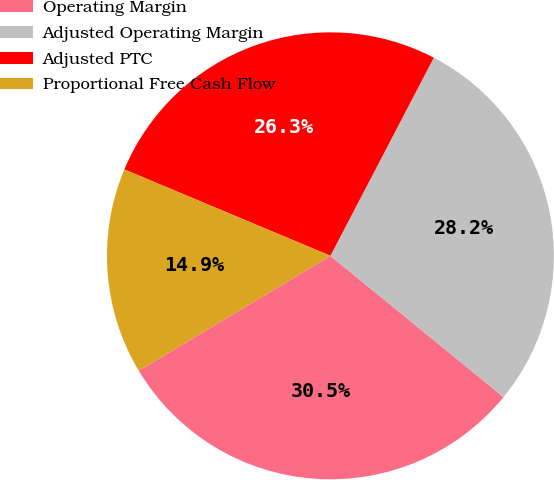Convert chart to OTSL. <chart><loc_0><loc_0><loc_500><loc_500><pie_chart><fcel>Operating Margin<fcel>Adjusted Operating Margin<fcel>Adjusted PTC<fcel>Proportional Free Cash Flow<nl><fcel>30.51%<fcel>28.24%<fcel>26.34%<fcel>14.91%<nl></chart> 